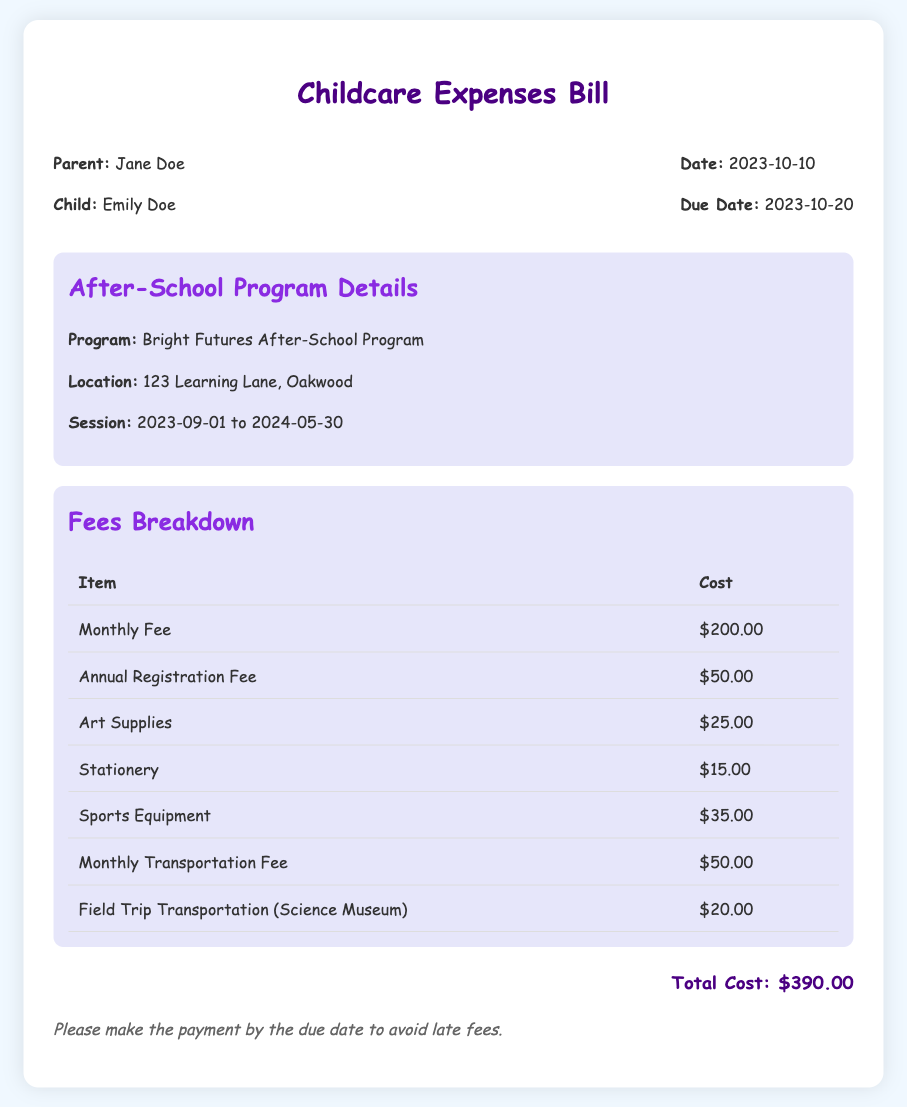What is the parent's name? The parent's name is specified at the beginning of the document.
Answer: Jane Doe What is the child's name? The child's name is provided alongside the parent's name in the document.
Answer: Emily Doe What is the total cost? The total cost is summarized at the end of the bill.
Answer: $390.00 What is the due date for the payment? The due date is mentioned in the header section of the bill.
Answer: 2023-10-20 How much is the Monthly Fee? The Monthly Fee is listed in the fees breakdown table.
Answer: $200.00 How many items are listed in the Fees Breakdown? The number of items can be counted from the fees breakdown table.
Answer: 6 What is the location of the After-School Program? The location is detailed in the After-School Program Details section.
Answer: 123 Learning Lane, Oakwood What is included in the transportation costs? Transportation costs are broken down in the Fees Breakdown table.
Answer: Monthly Transportation Fee, Field Trip Transportation What is the session duration? The session duration is stated in the After-School Program Details section.
Answer: 2023-09-01 to 2024-05-30 